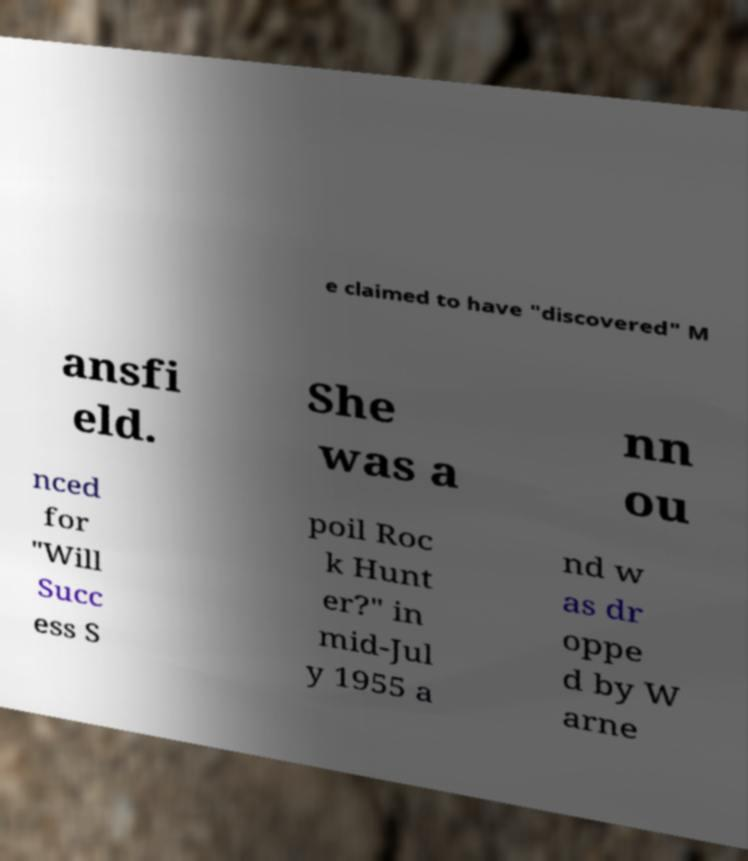What messages or text are displayed in this image? I need them in a readable, typed format. e claimed to have "discovered" M ansfi eld. She was a nn ou nced for "Will Succ ess S poil Roc k Hunt er?" in mid-Jul y 1955 a nd w as dr oppe d by W arne 